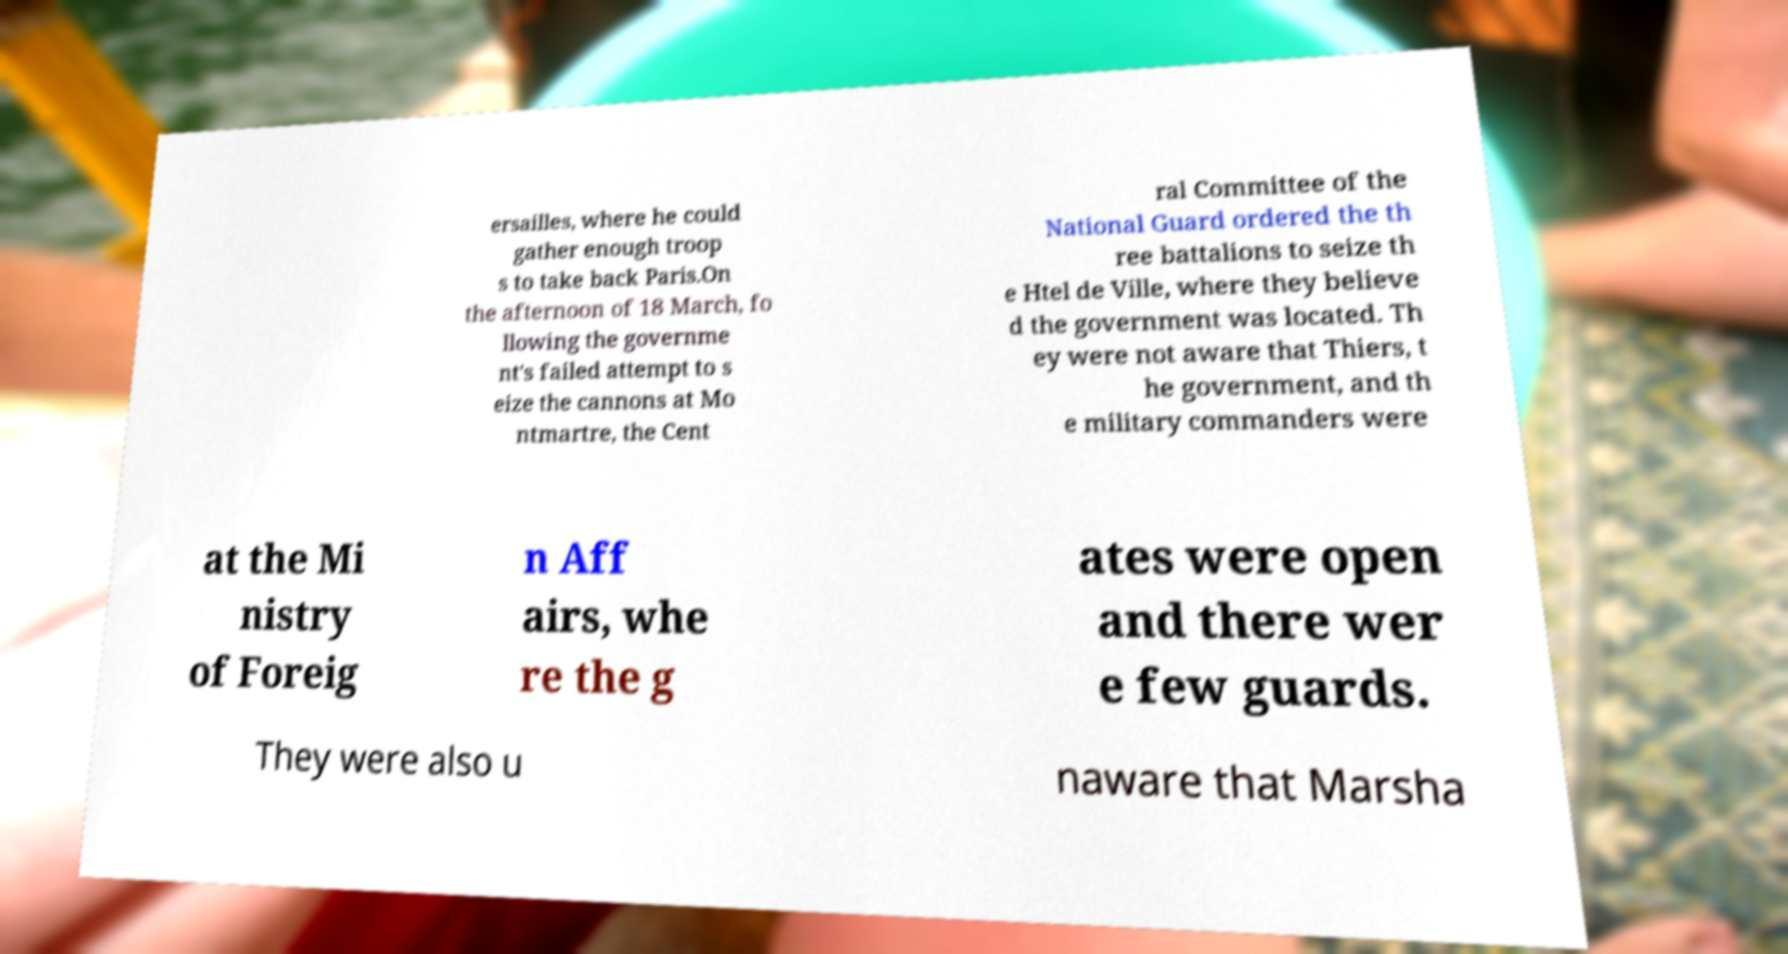I need the written content from this picture converted into text. Can you do that? ersailles, where he could gather enough troop s to take back Paris.On the afternoon of 18 March, fo llowing the governme nt's failed attempt to s eize the cannons at Mo ntmartre, the Cent ral Committee of the National Guard ordered the th ree battalions to seize th e Htel de Ville, where they believe d the government was located. Th ey were not aware that Thiers, t he government, and th e military commanders were at the Mi nistry of Foreig n Aff airs, whe re the g ates were open and there wer e few guards. They were also u naware that Marsha 